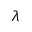<formula> <loc_0><loc_0><loc_500><loc_500>\lambda</formula> 